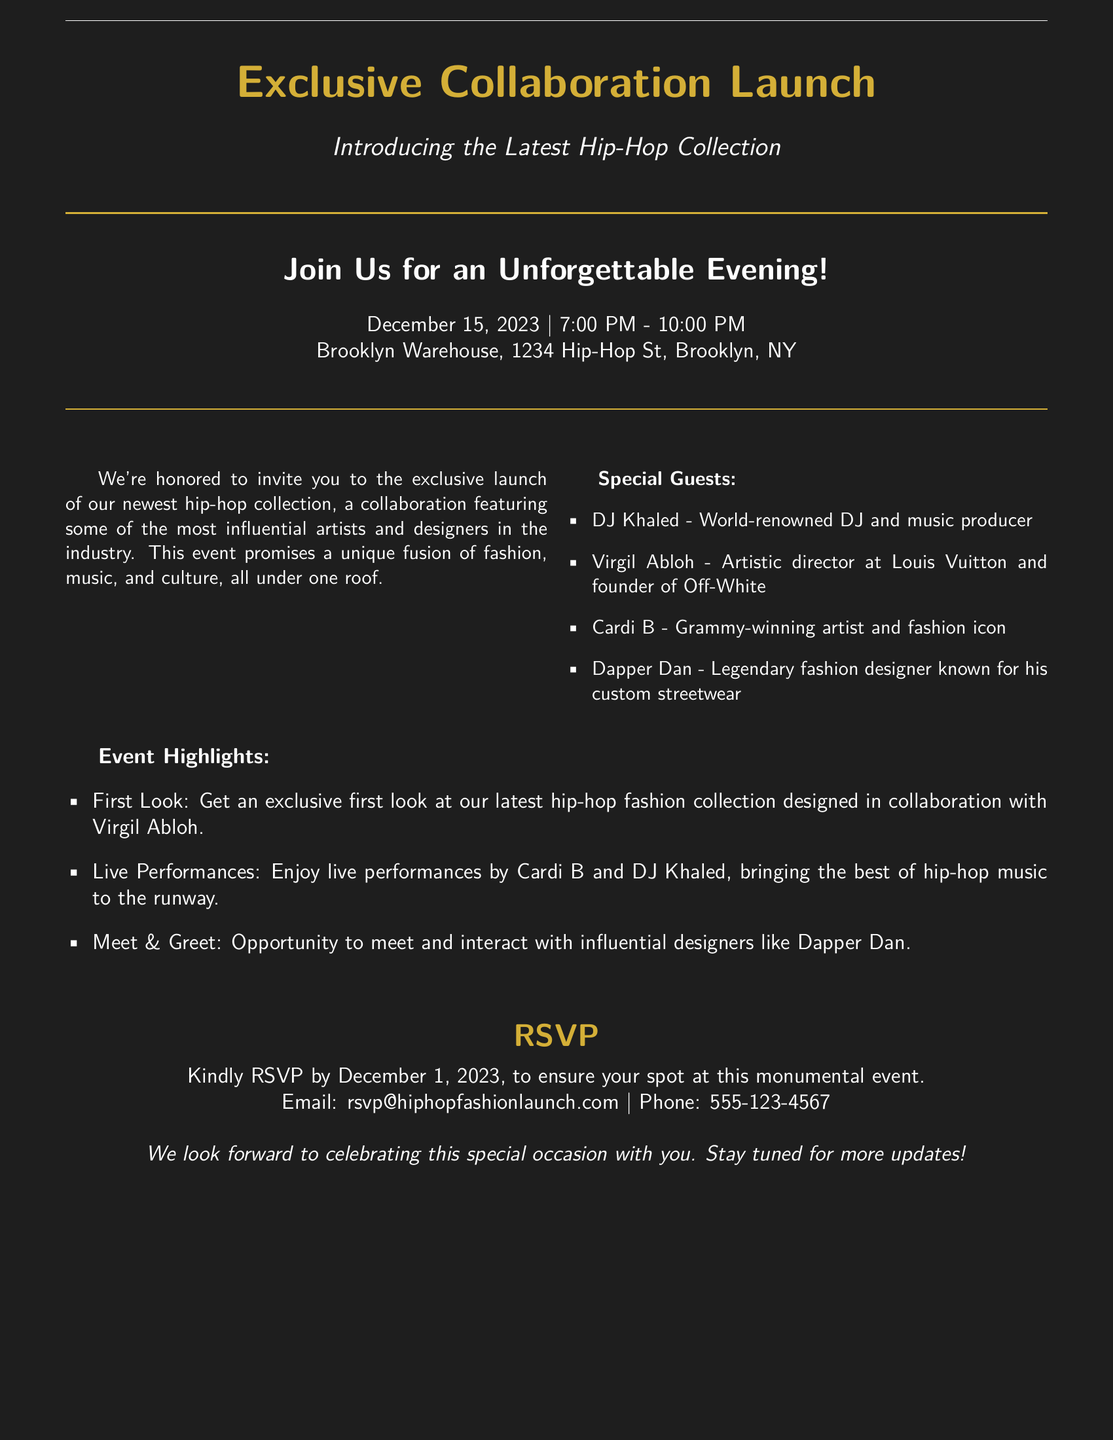What date is the event scheduled for? The date of the event is specified in the document, which indicates that it is December 15, 2023.
Answer: December 15, 2023 Who are some of the special guests attending? The document lists several special guests, including DJ Khaled, Virgil Abloh, Cardi B, and Dapper Dan.
Answer: DJ Khaled, Virgil Abloh, Cardi B, Dapper Dan What time does the event start? The start time for the event is clearly mentioned in the document, which states it begins at 7:00 PM.
Answer: 7:00 PM When is the RSVP deadline? The document specifies the deadline for RSVPs, which is December 1, 2023.
Answer: December 1, 2023 What will be highlighted at the event? The document outlines specific highlights that include the first look at a fashion collection, live performances, and a meet & greet.
Answer: First look, live performances, meet & greet Which artist will perform live at the event? The document mentions Cardi B and DJ Khaled as the artists performing live at the event.
Answer: Cardi B, DJ Khaled Where is the event taking place? The location of the event is provided in the document, stating it will be held at Brooklyn Warehouse, 1234 Hip-Hop St, Brooklyn, NY.
Answer: Brooklyn Warehouse, 1234 Hip-Hop St, Brooklyn, NY What type of event is this? The document indicates that this is an exclusive launch event for a hip-hop fashion collection.
Answer: Exclusive launch event 